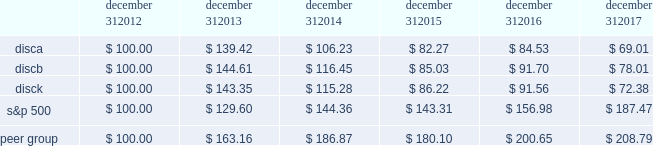Part ii item 5 .
Market for registrant 2019s common equity , related stockholder matters and issuer purchases of equity securities .
Our series a common stock , series b common stock and series c common stock are listed and traded on the nasdaq global select market ( 201cnasdaq 201d ) under the symbols 201cdisca , 201d 201cdiscb 201d and 201cdisck , 201d respectively .
The table sets forth , for the periods indicated , the range of high and low sales prices per share of our series a common stock , series b common stock and series c common stock as reported on yahoo! finance ( finance.yahoo.com ) .
Series a common stock series b common stock series c common stock high low high low high low fourth quarter $ 23.73 $ 16.28 $ 26.80 $ 20.00 $ 22.47 $ 15.27 third quarter $ 27.18 $ 20.80 $ 27.90 $ 22.00 $ 26.21 $ 19.62 second quarter $ 29.40 $ 25.11 $ 29.55 $ 25.45 $ 28.90 $ 24.39 first quarter $ 29.62 $ 26.34 $ 29.65 $ 27.55 $ 28.87 $ 25.76 fourth quarter $ 29.55 $ 25.01 $ 30.50 $ 26.00 $ 28.66 $ 24.20 third quarter $ 26.97 $ 24.27 $ 28.00 $ 25.21 $ 26.31 $ 23.44 second quarter $ 29.31 $ 23.73 $ 29.34 $ 24.15 $ 28.48 $ 22.54 first quarter $ 29.42 $ 24.33 $ 29.34 $ 24.30 $ 28.00 $ 23.81 as of february 21 , 2018 , there were approximately 1308 , 75 and 1414 record holders of our series a common stock , series b common stock and series c common stock , respectively .
These amounts do not include the number of shareholders whose shares are held of record by banks , brokerage houses or other institutions , but include each such institution as one shareholder .
We have not paid any cash dividends on our series a common stock , series b common stock or series c common stock , and we have no present intention to do so .
Payment of cash dividends , if any , will be determined by our board of directors after consideration of our earnings , financial condition and other relevant factors such as our credit facility's restrictions on our ability to declare dividends in certain situations .
Purchases of equity securities the table presents information about our repurchases of common stock that were made through open market transactions during the three months ended december 31 , 2017 ( in millions , except per share amounts ) .
Period total number of series c shares purchased average paid per share : series c ( a ) total number of shares purchased as part of publicly announced plans or programs ( b ) ( c ) approximate dollar value of shares that may yet be purchased under the plans or programs ( a ) ( b ) october 1 , 2017 - october 31 , 2017 2014 $ 2014 2014 $ 2014 november 1 , 2017 - november 30 , 2017 2014 $ 2014 2014 $ 2014 december 1 , 2017 - december 31 , 2017 2014 $ 2014 2014 $ 2014 total 2014 2014 $ 2014 ( a ) the amounts do not give effect to any fees , commissions or other costs associated with repurchases of shares .
( b ) under the stock repurchase program , management was authorized to purchase shares of the company's common stock from time to time through open market purchases or privately negotiated transactions at prevailing prices or pursuant to one or more accelerated stock repurchase agreements or other derivative arrangements as permitted by securities laws and other legal requirements , and subject to stock price , business and market conditions and other factors .
The company's authorization under the program expired on october 8 , 2017 and we have not repurchased any shares of common stock since then .
We historically have funded and in the future may fund stock repurchases through a combination of cash on hand and cash generated by operations and the issuance of debt .
In the future , if further authorization is provided , we may also choose to fund stock repurchases through borrowings under our revolving credit facility or future financing transactions .
There were no repurchases of our series a and b common stock during 2017 and no repurchases of series c common stock during the three months ended december 31 , 2017 .
The company first announced its stock repurchase program on august 3 , 2010 .
( c ) we entered into an agreement with advance/newhouse to repurchase , on a quarterly basis , a number of shares of series c-1 convertible preferred stock convertible into a number of shares of series c common stock .
We did not convert any any shares of series c-1 convertible preferred stock during the three months ended december 31 , 2017 .
There are no planned repurchases of series c-1 convertible preferred stock for the first quarter of 2018 as there were no repurchases of series a or series c common stock during the three months ended december 31 , 2017 .
Stock performance graph the following graph sets forth the cumulative total shareholder return on our series a common stock , series b common stock and series c common stock as compared with the cumulative total return of the companies listed in the standard and poor 2019s 500 stock index ( 201cs&p 500 index 201d ) and a peer group of companies comprised of cbs corporation class b common stock , scripps network interactive , inc. , time warner , inc. , twenty-first century fox , inc .
Class a common stock ( news corporation class a common stock prior to june 2013 ) , viacom , inc .
Class b common stock and the walt disney company .
The graph assumes $ 100 originally invested on december 31 , 2012 in each of our series a common stock , series b common stock and series c common stock , the s&p 500 index , and the stock of our peer group companies , including reinvestment of dividends , for the years ended december 31 , 2013 , 2014 , 2015 , 2016 and 2017 .
December 31 , december 31 , december 31 , december 31 , december 31 , december 31 .

As of february 21 , 2018 what were the total number of shareholders of common stock?\\n? 
Computations: ((1308 + 75) + 1414)
Answer: 2797.0. 